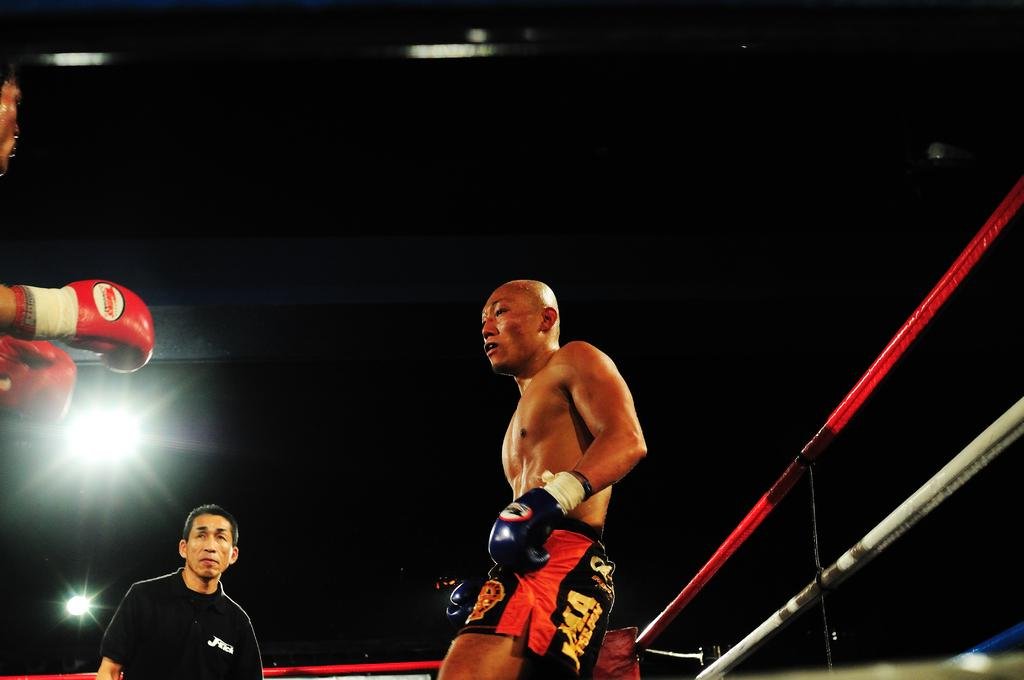How many people are inside the boxing ring in the image? There are two players inside the boxing ring in the image. What is the role of the person in the image who is not a player? There is a referee in the image. What can be observed about the lighting in the image? The background of the image is dark. What type of wire can be seen hanging from the mouth of one of the players in the image? There is no wire visible in the image, and no player has a wire hanging from their mouth. 